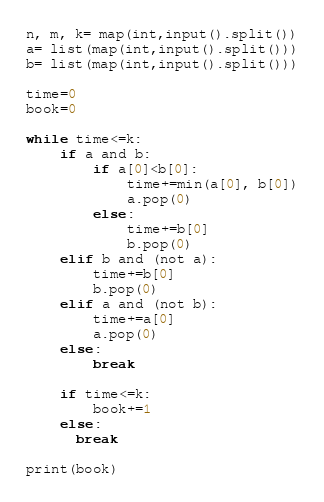<code> <loc_0><loc_0><loc_500><loc_500><_Python_>n, m, k= map(int,input().split())
a= list(map(int,input().split()))
b= list(map(int,input().split()))

time=0
book=0

while time<=k:
    if a and b:
        if a[0]<b[0]:
            time+=min(a[0], b[0])
            a.pop(0)
        else:
            time+=b[0]
            b.pop(0)
    elif b and (not a):
        time+=b[0]
        b.pop(0)
    elif a and (not b):
        time+=a[0]
        a.pop(0)
    else:
        break
        
    if time<=k:
    	book+=1
    else:
      break

print(book)</code> 